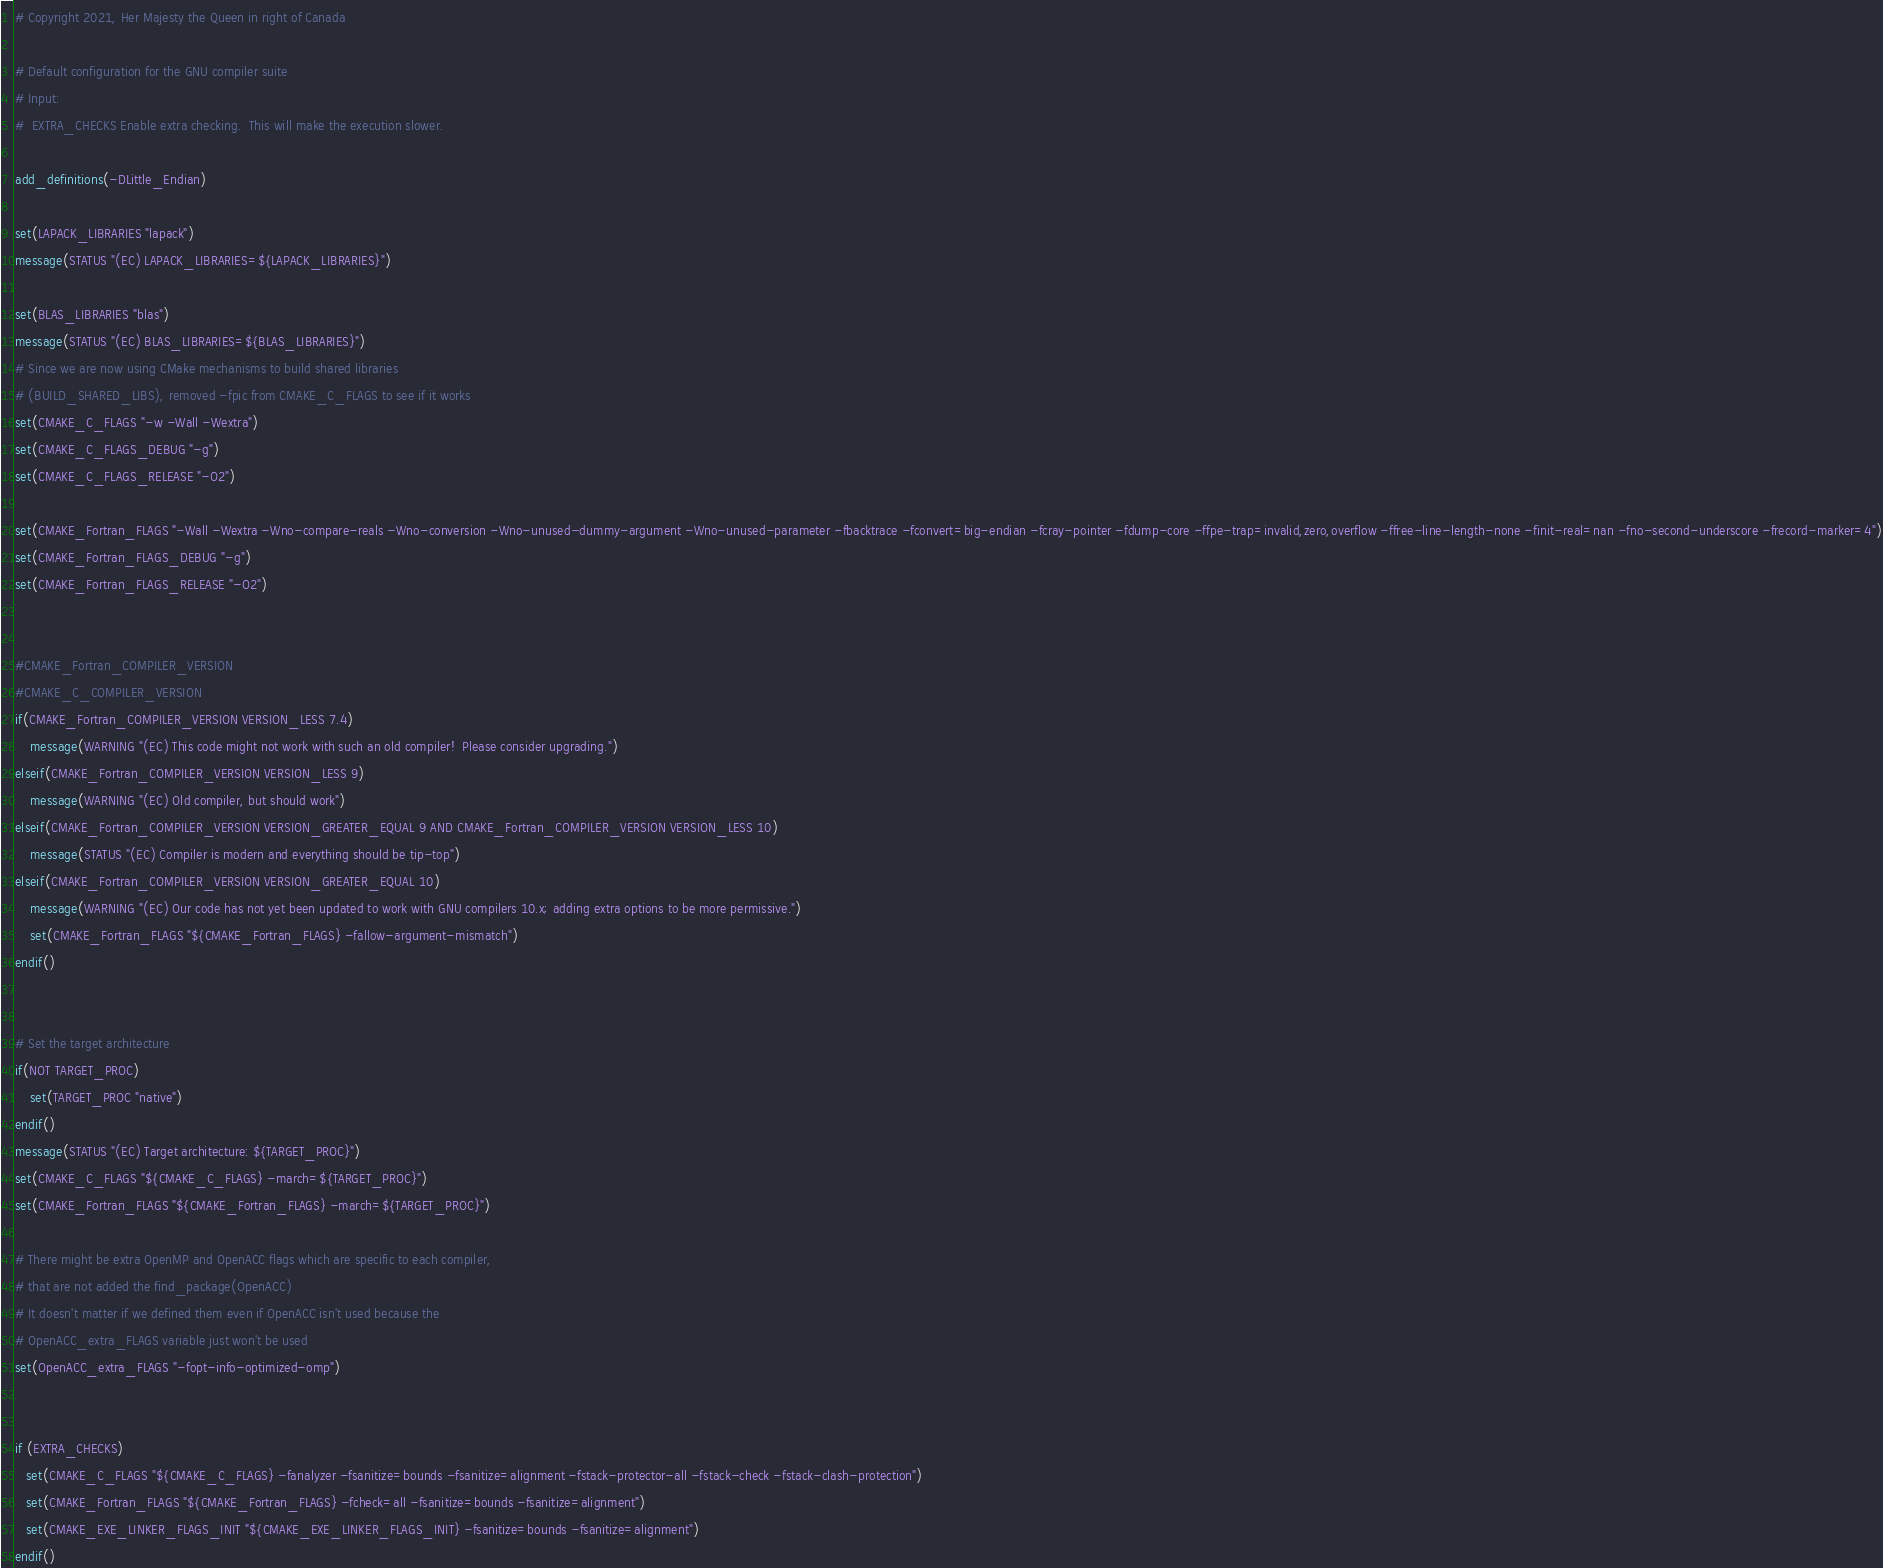Convert code to text. <code><loc_0><loc_0><loc_500><loc_500><_CMake_># Copyright 2021, Her Majesty the Queen in right of Canada

# Default configuration for the GNU compiler suite
# Input:
#  EXTRA_CHECKS Enable extra checking.  This will make the execution slower.

add_definitions(-DLittle_Endian)

set(LAPACK_LIBRARIES "lapack")
message(STATUS "(EC) LAPACK_LIBRARIES=${LAPACK_LIBRARIES}")

set(BLAS_LIBRARIES "blas")
message(STATUS "(EC) BLAS_LIBRARIES=${BLAS_LIBRARIES}")
# Since we are now using CMake mechanisms to build shared libraries
# (BUILD_SHARED_LIBS), removed -fpic from CMAKE_C_FLAGS to see if it works
set(CMAKE_C_FLAGS "-w -Wall -Wextra")
set(CMAKE_C_FLAGS_DEBUG "-g")
set(CMAKE_C_FLAGS_RELEASE "-O2")

set(CMAKE_Fortran_FLAGS "-Wall -Wextra -Wno-compare-reals -Wno-conversion -Wno-unused-dummy-argument -Wno-unused-parameter -fbacktrace -fconvert=big-endian -fcray-pointer -fdump-core -ffpe-trap=invalid,zero,overflow -ffree-line-length-none -finit-real=nan -fno-second-underscore -frecord-marker=4")
set(CMAKE_Fortran_FLAGS_DEBUG "-g")
set(CMAKE_Fortran_FLAGS_RELEASE "-O2")


#CMAKE_Fortran_COMPILER_VERSION
#CMAKE_C_COMPILER_VERSION
if(CMAKE_Fortran_COMPILER_VERSION VERSION_LESS 7.4)
    message(WARNING "(EC) This code might not work with such an old compiler!  Please consider upgrading.")
elseif(CMAKE_Fortran_COMPILER_VERSION VERSION_LESS 9)
    message(WARNING "(EC) Old compiler, but should work")
elseif(CMAKE_Fortran_COMPILER_VERSION VERSION_GREATER_EQUAL 9 AND CMAKE_Fortran_COMPILER_VERSION VERSION_LESS 10)
    message(STATUS "(EC) Compiler is modern and everything should be tip-top")
elseif(CMAKE_Fortran_COMPILER_VERSION VERSION_GREATER_EQUAL 10)
    message(WARNING "(EC) Our code has not yet been updated to work with GNU compilers 10.x; adding extra options to be more permissive.")
    set(CMAKE_Fortran_FLAGS "${CMAKE_Fortran_FLAGS} -fallow-argument-mismatch")
endif()


# Set the target architecture
if(NOT TARGET_PROC)
    set(TARGET_PROC "native")
endif()
message(STATUS "(EC) Target architecture: ${TARGET_PROC}")
set(CMAKE_C_FLAGS "${CMAKE_C_FLAGS} -march=${TARGET_PROC}")
set(CMAKE_Fortran_FLAGS "${CMAKE_Fortran_FLAGS} -march=${TARGET_PROC}")

# There might be extra OpenMP and OpenACC flags which are specific to each compiler,
# that are not added the find_package(OpenACC)
# It doesn't matter if we defined them even if OpenACC isn't used because the
# OpenACC_extra_FLAGS variable just won't be used
set(OpenACC_extra_FLAGS "-fopt-info-optimized-omp")


if (EXTRA_CHECKS)
   set(CMAKE_C_FLAGS "${CMAKE_C_FLAGS} -fanalyzer -fsanitize=bounds -fsanitize=alignment -fstack-protector-all -fstack-check -fstack-clash-protection")
   set(CMAKE_Fortran_FLAGS "${CMAKE_Fortran_FLAGS} -fcheck=all -fsanitize=bounds -fsanitize=alignment")
   set(CMAKE_EXE_LINKER_FLAGS_INIT "${CMAKE_EXE_LINKER_FLAGS_INIT} -fsanitize=bounds -fsanitize=alignment")
endif()
</code> 